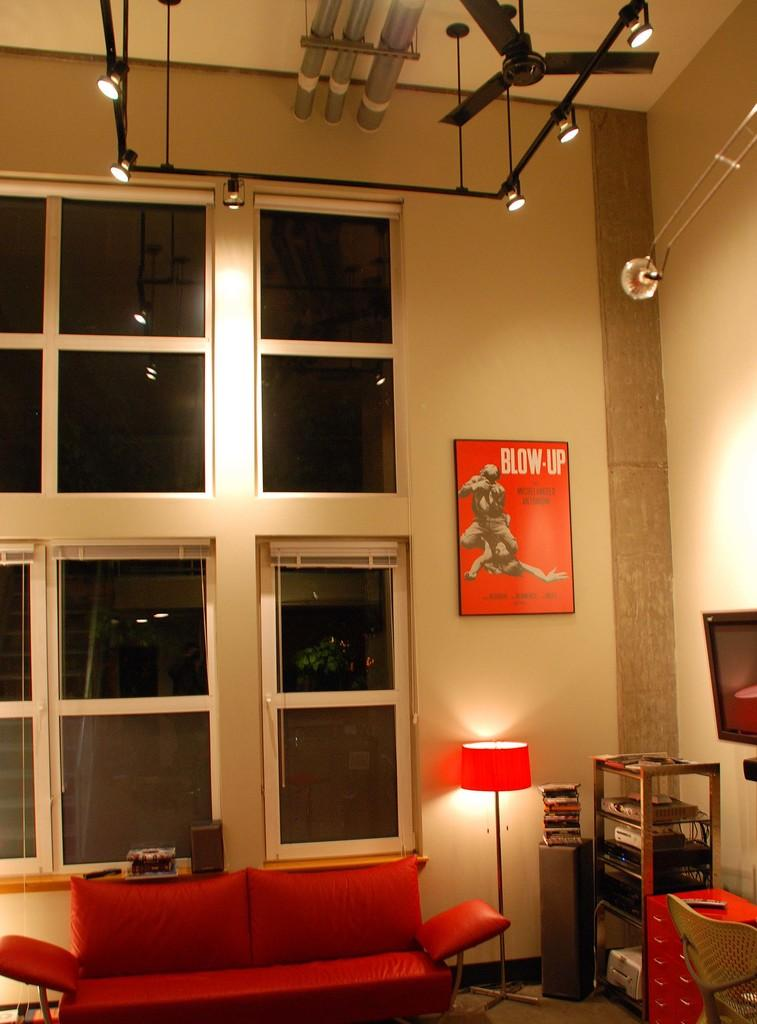What type of space is depicted in the image? There is a room in the image. What furniture is present in the room? There is a sofa set in the room. What type of lighting is available in the room? There is a lamp in the room. What decorative item can be seen on the wall in the room? There is a poster on the wall in the room. What type of shirt is the person wearing in the image? There is no person present in the image, so it is not possible to determine what type of shirt they might be wearing. 